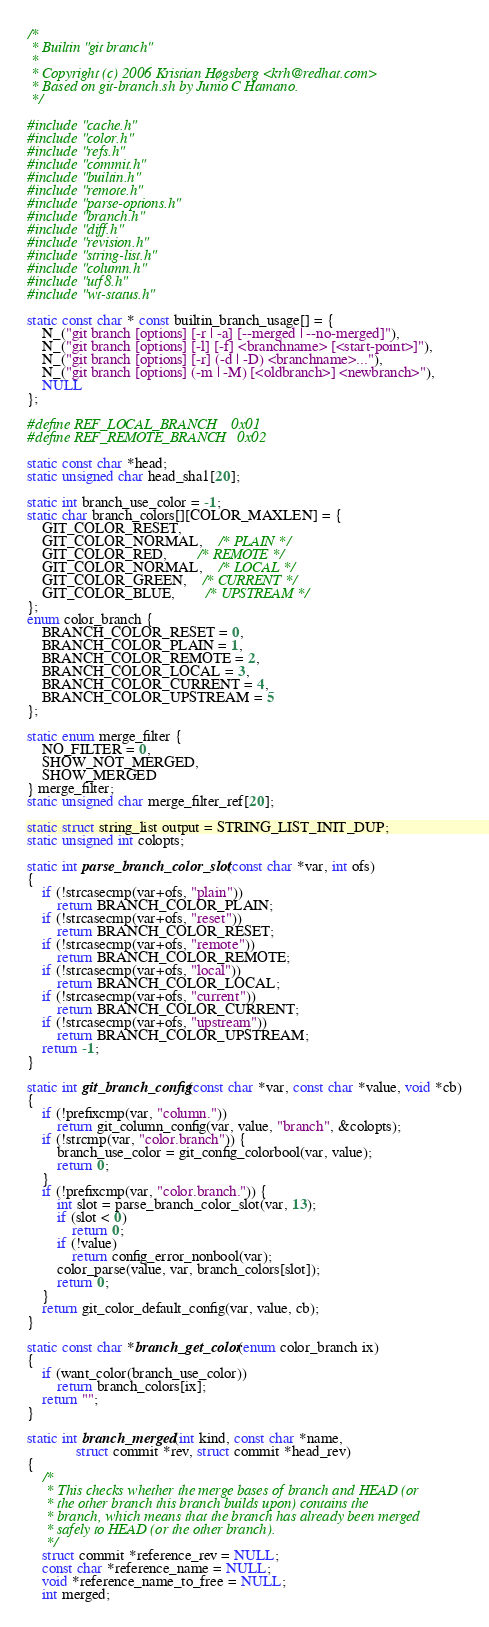Convert code to text. <code><loc_0><loc_0><loc_500><loc_500><_C_>/*
 * Builtin "git branch"
 *
 * Copyright (c) 2006 Kristian Høgsberg <krh@redhat.com>
 * Based on git-branch.sh by Junio C Hamano.
 */

#include "cache.h"
#include "color.h"
#include "refs.h"
#include "commit.h"
#include "builtin.h"
#include "remote.h"
#include "parse-options.h"
#include "branch.h"
#include "diff.h"
#include "revision.h"
#include "string-list.h"
#include "column.h"
#include "utf8.h"
#include "wt-status.h"

static const char * const builtin_branch_usage[] = {
	N_("git branch [options] [-r | -a] [--merged | --no-merged]"),
	N_("git branch [options] [-l] [-f] <branchname> [<start-point>]"),
	N_("git branch [options] [-r] (-d | -D) <branchname>..."),
	N_("git branch [options] (-m | -M) [<oldbranch>] <newbranch>"),
	NULL
};

#define REF_LOCAL_BRANCH    0x01
#define REF_REMOTE_BRANCH   0x02

static const char *head;
static unsigned char head_sha1[20];

static int branch_use_color = -1;
static char branch_colors[][COLOR_MAXLEN] = {
	GIT_COLOR_RESET,
	GIT_COLOR_NORMAL,	/* PLAIN */
	GIT_COLOR_RED,		/* REMOTE */
	GIT_COLOR_NORMAL,	/* LOCAL */
	GIT_COLOR_GREEN,	/* CURRENT */
	GIT_COLOR_BLUE,		/* UPSTREAM */
};
enum color_branch {
	BRANCH_COLOR_RESET = 0,
	BRANCH_COLOR_PLAIN = 1,
	BRANCH_COLOR_REMOTE = 2,
	BRANCH_COLOR_LOCAL = 3,
	BRANCH_COLOR_CURRENT = 4,
	BRANCH_COLOR_UPSTREAM = 5
};

static enum merge_filter {
	NO_FILTER = 0,
	SHOW_NOT_MERGED,
	SHOW_MERGED
} merge_filter;
static unsigned char merge_filter_ref[20];

static struct string_list output = STRING_LIST_INIT_DUP;
static unsigned int colopts;

static int parse_branch_color_slot(const char *var, int ofs)
{
	if (!strcasecmp(var+ofs, "plain"))
		return BRANCH_COLOR_PLAIN;
	if (!strcasecmp(var+ofs, "reset"))
		return BRANCH_COLOR_RESET;
	if (!strcasecmp(var+ofs, "remote"))
		return BRANCH_COLOR_REMOTE;
	if (!strcasecmp(var+ofs, "local"))
		return BRANCH_COLOR_LOCAL;
	if (!strcasecmp(var+ofs, "current"))
		return BRANCH_COLOR_CURRENT;
	if (!strcasecmp(var+ofs, "upstream"))
		return BRANCH_COLOR_UPSTREAM;
	return -1;
}

static int git_branch_config(const char *var, const char *value, void *cb)
{
	if (!prefixcmp(var, "column."))
		return git_column_config(var, value, "branch", &colopts);
	if (!strcmp(var, "color.branch")) {
		branch_use_color = git_config_colorbool(var, value);
		return 0;
	}
	if (!prefixcmp(var, "color.branch.")) {
		int slot = parse_branch_color_slot(var, 13);
		if (slot < 0)
			return 0;
		if (!value)
			return config_error_nonbool(var);
		color_parse(value, var, branch_colors[slot]);
		return 0;
	}
	return git_color_default_config(var, value, cb);
}

static const char *branch_get_color(enum color_branch ix)
{
	if (want_color(branch_use_color))
		return branch_colors[ix];
	return "";
}

static int branch_merged(int kind, const char *name,
			 struct commit *rev, struct commit *head_rev)
{
	/*
	 * This checks whether the merge bases of branch and HEAD (or
	 * the other branch this branch builds upon) contains the
	 * branch, which means that the branch has already been merged
	 * safely to HEAD (or the other branch).
	 */
	struct commit *reference_rev = NULL;
	const char *reference_name = NULL;
	void *reference_name_to_free = NULL;
	int merged;
</code> 